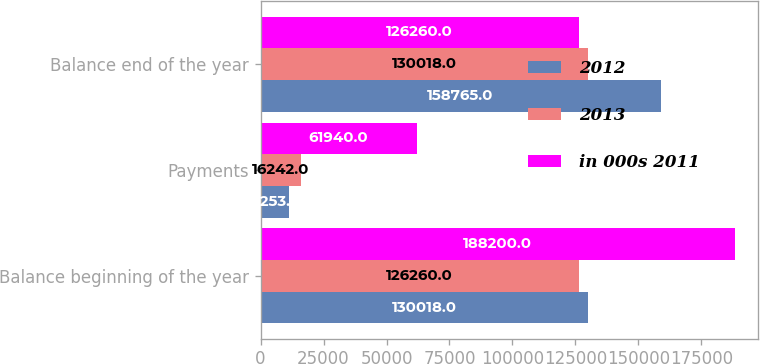<chart> <loc_0><loc_0><loc_500><loc_500><stacked_bar_chart><ecel><fcel>Balance beginning of the year<fcel>Payments<fcel>Balance end of the year<nl><fcel>2012<fcel>130018<fcel>11253<fcel>158765<nl><fcel>2013<fcel>126260<fcel>16242<fcel>130018<nl><fcel>in 000s 2011<fcel>188200<fcel>61940<fcel>126260<nl></chart> 